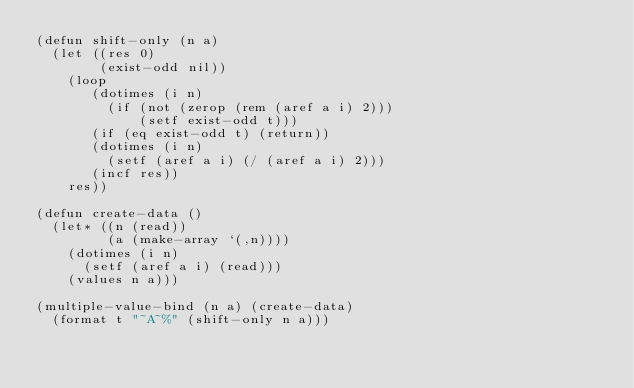<code> <loc_0><loc_0><loc_500><loc_500><_Lisp_>(defun shift-only (n a)
  (let ((res 0)
        (exist-odd nil))
    (loop
       (dotimes (i n)
         (if (not (zerop (rem (aref a i) 2)))
             (setf exist-odd t)))
       (if (eq exist-odd t) (return))
       (dotimes (i n)
         (setf (aref a i) (/ (aref a i) 2)))
       (incf res))
    res))

(defun create-data ()
  (let* ((n (read))
         (a (make-array `(,n))))
    (dotimes (i n)
      (setf (aref a i) (read)))
    (values n a)))

(multiple-value-bind (n a) (create-data)
  (format t "~A~%" (shift-only n a)))</code> 